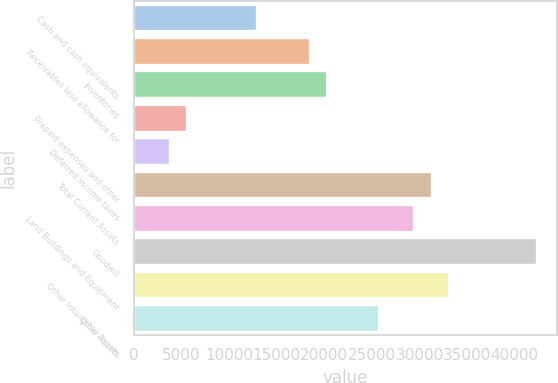<chart> <loc_0><loc_0><loc_500><loc_500><bar_chart><fcel>Cash and cash equivalents<fcel>Receivables less allowance for<fcel>Inventories<fcel>Prepaid expenses and other<fcel>Deferred income taxes<fcel>Total Current Assets<fcel>Land Buildings and Equipment<fcel>Goodwill<fcel>Other Intangible Assets<fcel>Other Assets<nl><fcel>12940.3<fcel>18448<fcel>20283.9<fcel>5596.7<fcel>3760.8<fcel>31299.3<fcel>29463.4<fcel>42314.7<fcel>33135.2<fcel>25791.6<nl></chart> 